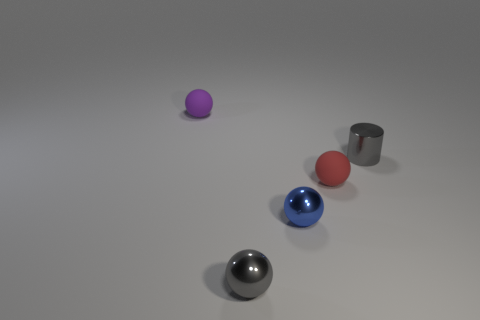What is the color of the small metallic cylinder?
Provide a short and direct response. Gray. Do the matte object on the left side of the red matte sphere and the metallic ball on the left side of the tiny blue shiny object have the same color?
Ensure brevity in your answer.  No. What size is the gray metal sphere?
Keep it short and to the point. Small. What is the size of the gray thing that is on the left side of the small blue sphere?
Provide a succinct answer. Small. There is a object that is behind the small red rubber thing and on the left side of the small cylinder; what is its shape?
Provide a short and direct response. Sphere. How many other objects are the same shape as the small purple thing?
Make the answer very short. 3. There is a metal cylinder that is the same size as the red object; what color is it?
Provide a short and direct response. Gray. What number of objects are blue balls or small gray metallic things?
Offer a terse response. 3. There is a tiny purple matte object; are there any rubber things to the right of it?
Keep it short and to the point. Yes. Is there another sphere made of the same material as the red sphere?
Your answer should be compact. Yes. 